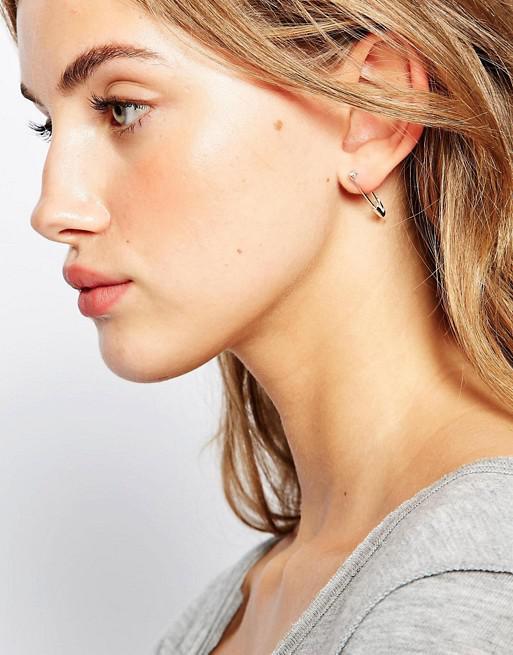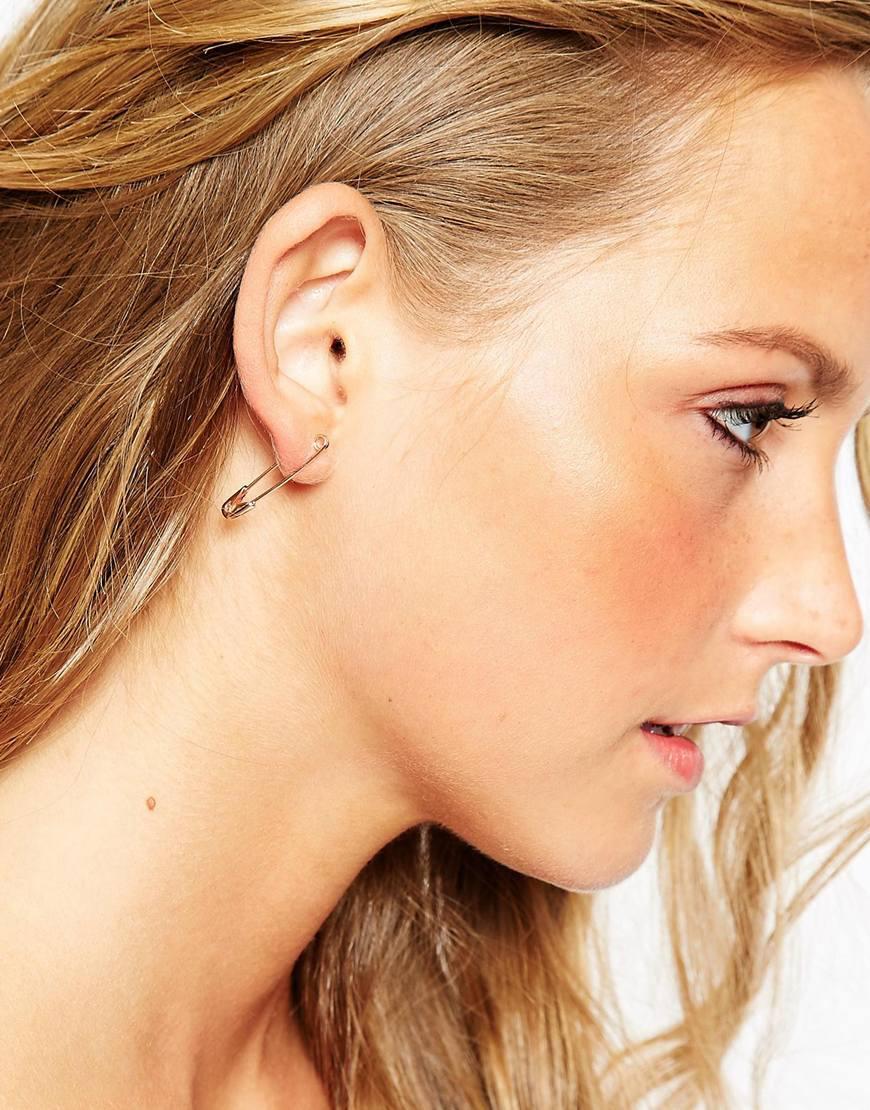The first image is the image on the left, the second image is the image on the right. Examine the images to the left and right. Is the description "There is a woman wearing a safety pin earring in each image." accurate? Answer yes or no. Yes. The first image is the image on the left, the second image is the image on the right. For the images displayed, is the sentence "In each image, a woman with blonde hair is shown from the side with a small safety pin, clasp end pointed down, being used as a earring." factually correct? Answer yes or no. Yes. 